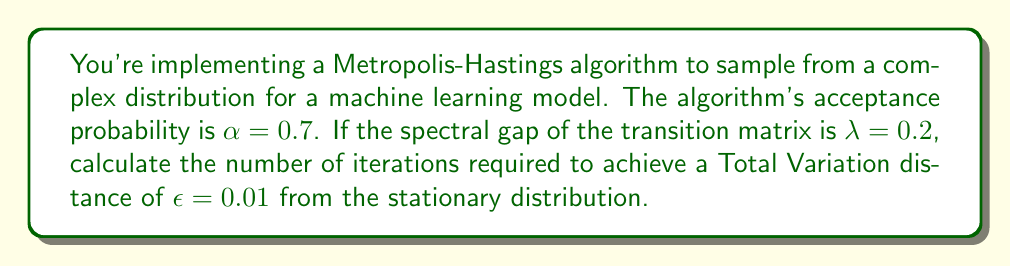Can you answer this question? To solve this problem, we'll use the convergence rate formula for Markov Chain Monte Carlo (MCMC) algorithms:

1) The convergence rate of an MCMC algorithm is determined by the second largest eigenvalue of the transition matrix, denoted as $\lambda_2$.

2) The spectral gap is defined as $\lambda = 1 - \lambda_2$.

3) Given $\lambda = 0.2$, we can calculate $\lambda_2$:
   $\lambda_2 = 1 - \lambda = 1 - 0.2 = 0.8$

4) The convergence rate is given by $\rho = \lambda_2 = 0.8$

5) The number of iterations $t$ required to achieve a Total Variation distance $\epsilon$ from the stationary distribution is given by:

   $$t \approx \frac{\log(\epsilon)}{\log(\rho)}$$

6) Substituting our values:

   $$t \approx \frac{\log(0.01)}{\log(0.8)}$$

7) Calculate:
   $$t \approx \frac{-4.605}{-0.223} \approx 20.65$$

8) Since we need a whole number of iterations, we round up to the nearest integer:
   $t = 21$

Therefore, approximately 21 iterations are required to achieve the desired convergence.
Answer: 21 iterations 